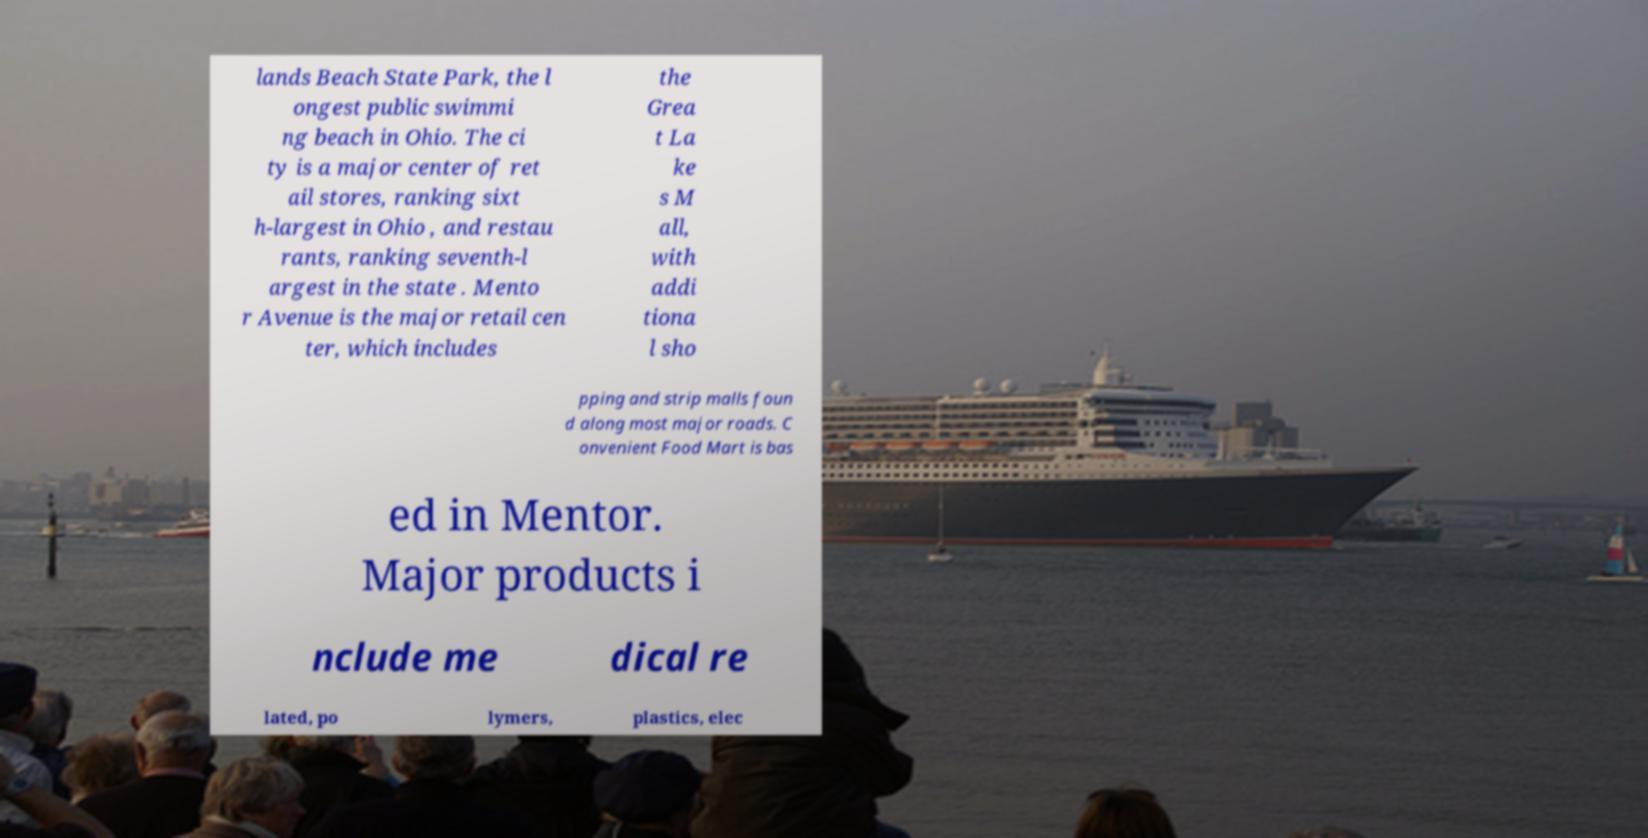Can you read and provide the text displayed in the image?This photo seems to have some interesting text. Can you extract and type it out for me? lands Beach State Park, the l ongest public swimmi ng beach in Ohio. The ci ty is a major center of ret ail stores, ranking sixt h-largest in Ohio , and restau rants, ranking seventh-l argest in the state . Mento r Avenue is the major retail cen ter, which includes the Grea t La ke s M all, with addi tiona l sho pping and strip malls foun d along most major roads. C onvenient Food Mart is bas ed in Mentor. Major products i nclude me dical re lated, po lymers, plastics, elec 